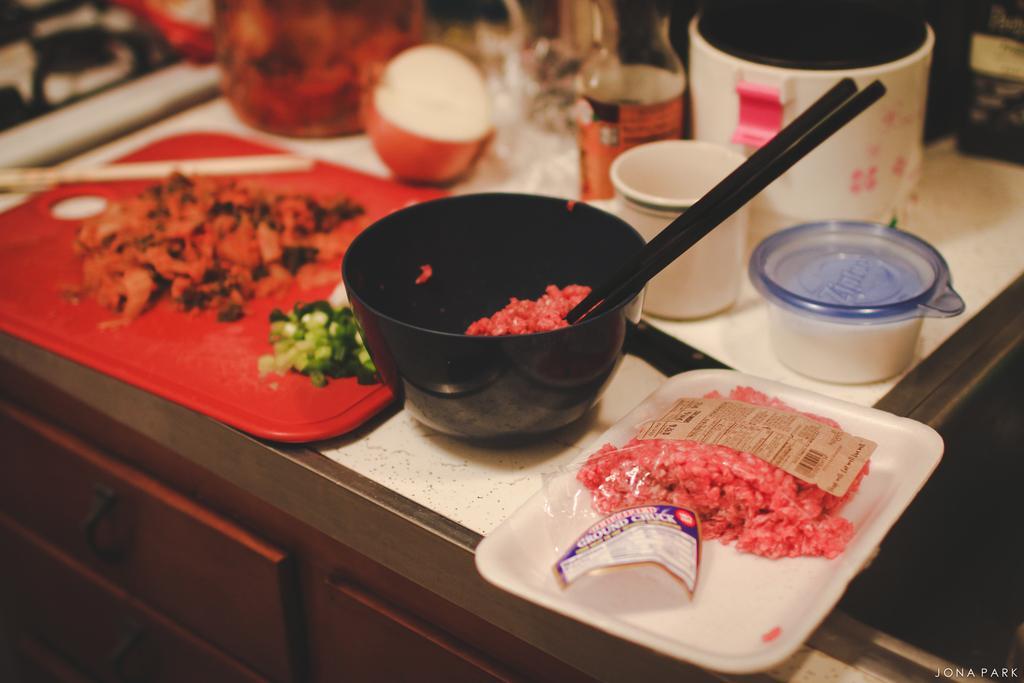In one or two sentences, can you explain what this image depicts? In the image we can see bowls, a tray, containers and food items. On the bottom right we can see the watermark and the top part of the image is slightly blurred. 